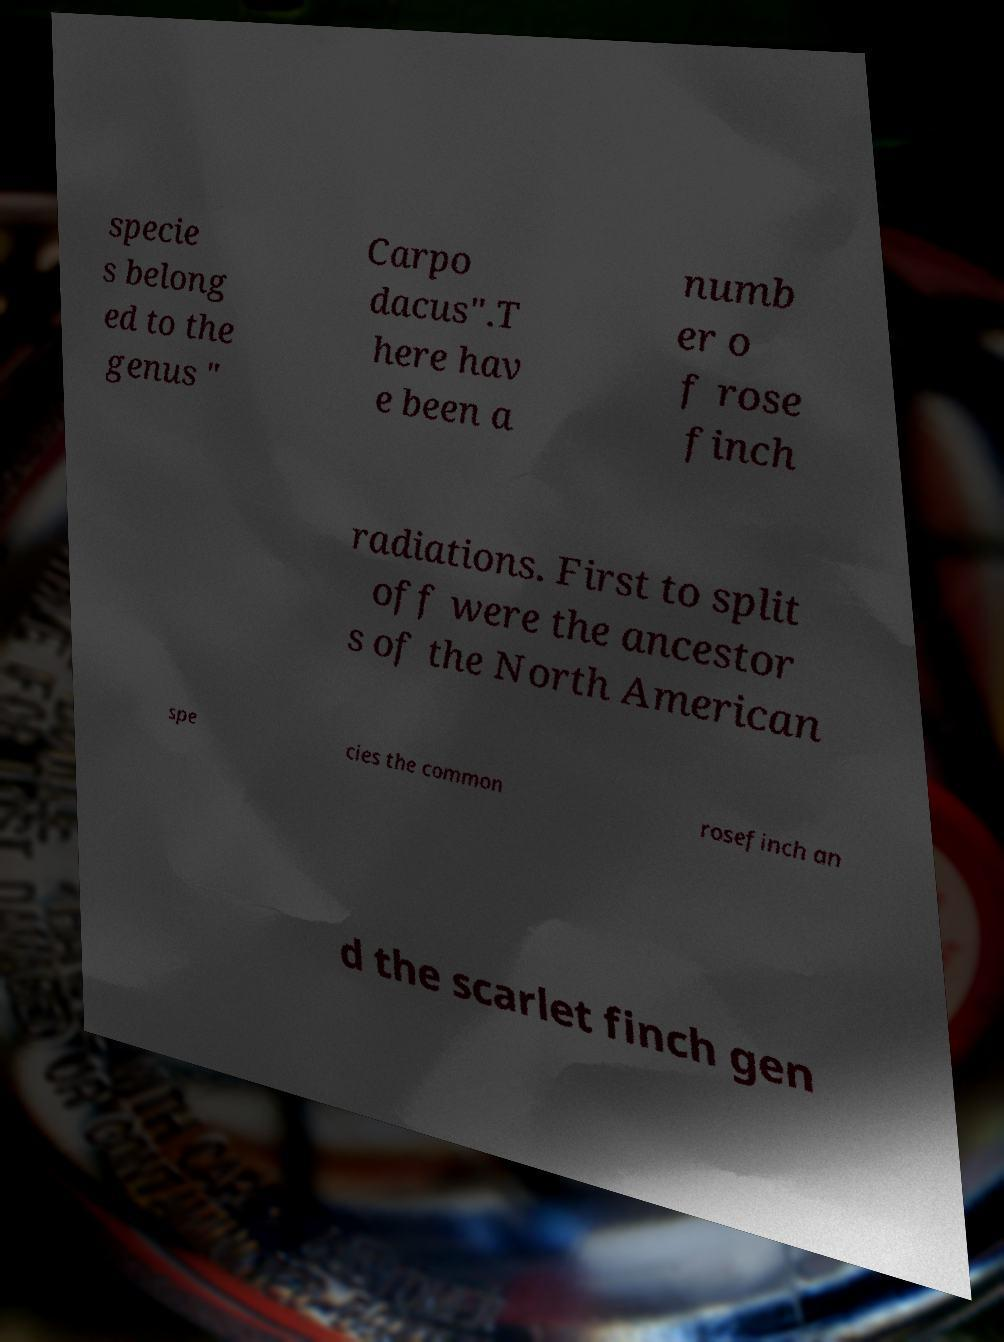Can you accurately transcribe the text from the provided image for me? specie s belong ed to the genus " Carpo dacus".T here hav e been a numb er o f rose finch radiations. First to split off were the ancestor s of the North American spe cies the common rosefinch an d the scarlet finch gen 